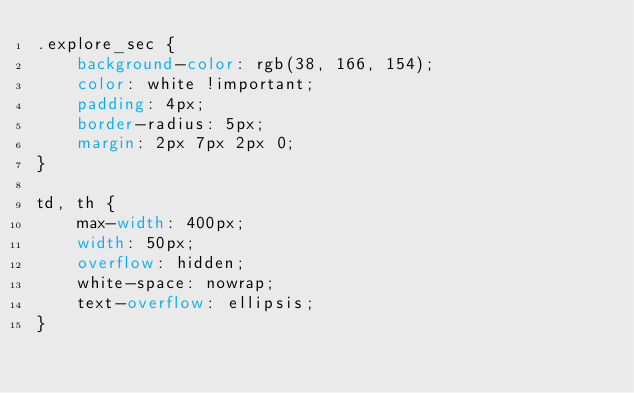<code> <loc_0><loc_0><loc_500><loc_500><_CSS_>.explore_sec {
    background-color: rgb(38, 166, 154);
    color: white !important;
    padding: 4px;
    border-radius: 5px;
    margin: 2px 7px 2px 0;
}

td, th {
    max-width: 400px;
    width: 50px;
    overflow: hidden;
    white-space: nowrap;
    text-overflow: ellipsis;
}</code> 